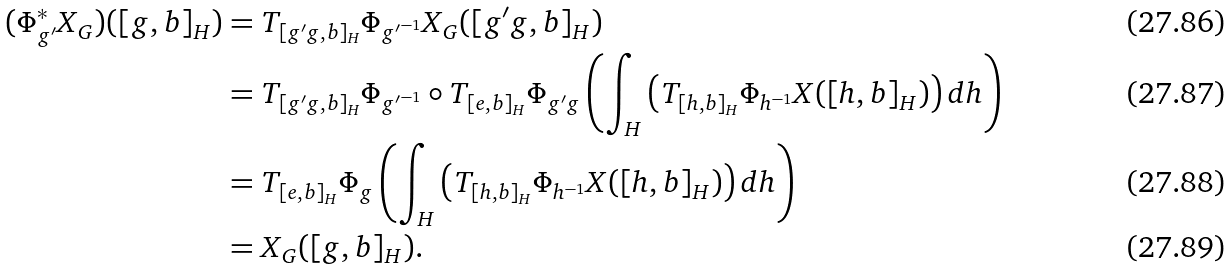Convert formula to latex. <formula><loc_0><loc_0><loc_500><loc_500>( \Phi _ { g ^ { \prime } } ^ { * } X _ { G } ) ( [ g , b ] _ { H } ) & = T _ { [ g ^ { \prime } g , b ] _ { H } } \Phi _ { { g ^ { \prime } } ^ { - 1 } } X _ { G } ( [ g ^ { \prime } g , b ] _ { H } ) \\ & = T _ { [ g ^ { \prime } g , b ] _ { H } } \Phi _ { { g ^ { \prime } } ^ { - 1 } } \circ T _ { [ e , b ] _ { H } } \Phi _ { g ^ { \prime } g } \left ( \int _ { H } \left ( T _ { [ h , b ] _ { H } } \Phi _ { h ^ { - 1 } } X ( [ h , b ] _ { H } ) \right ) d h \right ) \\ & = T _ { [ e , b ] _ { H } } \Phi _ { g } \left ( \int _ { H } \left ( T _ { [ h , b ] _ { H } } \Phi _ { h ^ { - 1 } } X ( [ h , b ] _ { H } ) \right ) d h \right ) \\ & = X _ { G } ( [ g , b ] _ { H } ) .</formula> 